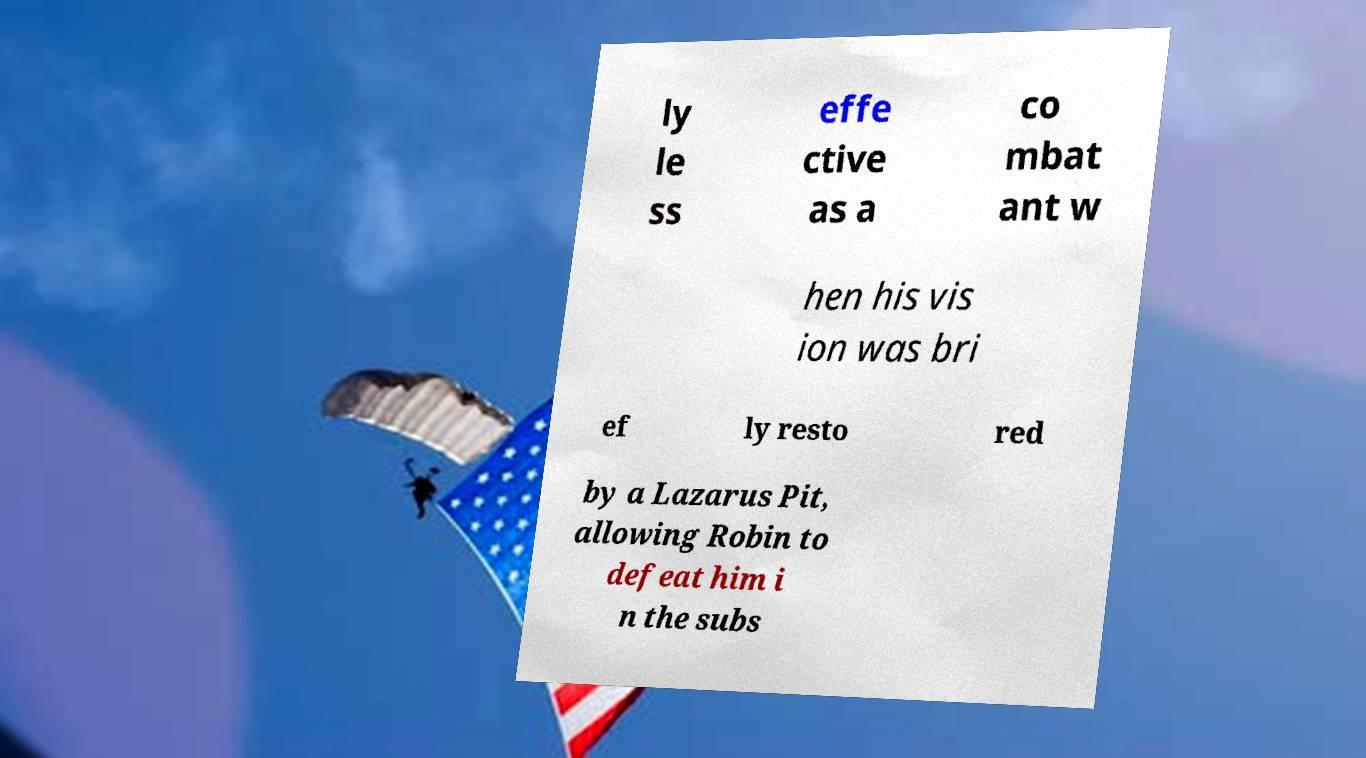For documentation purposes, I need the text within this image transcribed. Could you provide that? ly le ss effe ctive as a co mbat ant w hen his vis ion was bri ef ly resto red by a Lazarus Pit, allowing Robin to defeat him i n the subs 